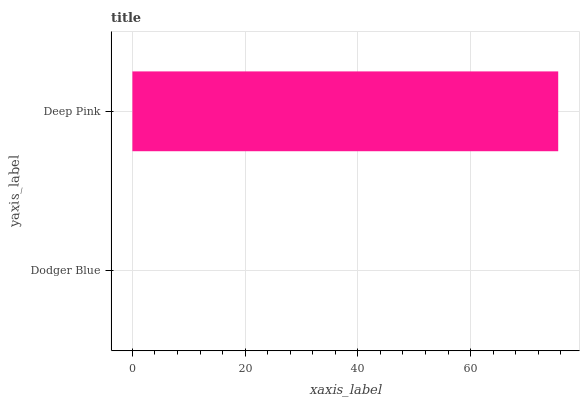Is Dodger Blue the minimum?
Answer yes or no. Yes. Is Deep Pink the maximum?
Answer yes or no. Yes. Is Deep Pink the minimum?
Answer yes or no. No. Is Deep Pink greater than Dodger Blue?
Answer yes or no. Yes. Is Dodger Blue less than Deep Pink?
Answer yes or no. Yes. Is Dodger Blue greater than Deep Pink?
Answer yes or no. No. Is Deep Pink less than Dodger Blue?
Answer yes or no. No. Is Deep Pink the high median?
Answer yes or no. Yes. Is Dodger Blue the low median?
Answer yes or no. Yes. Is Dodger Blue the high median?
Answer yes or no. No. Is Deep Pink the low median?
Answer yes or no. No. 